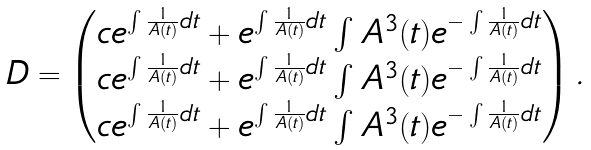Convert formula to latex. <formula><loc_0><loc_0><loc_500><loc_500>\begin{array} { l l } D = \begin{pmatrix} c e ^ { \int \frac { 1 } { A ( t ) } d t } + e ^ { \int \frac { 1 } { A ( t ) } d t } \int A ^ { 3 } ( t ) e ^ { - \int \frac { 1 } { A ( t ) } d t } \\ c e ^ { \int \frac { 1 } { A ( t ) } d t } + e ^ { \int \frac { 1 } { A ( t ) } d t } \int A ^ { 3 } ( t ) e ^ { - \int \frac { 1 } { A ( t ) } d t } \\ c e ^ { \int \frac { 1 } { A ( t ) } d t } + e ^ { \int \frac { 1 } { A ( t ) } d t } \int A ^ { 3 } ( t ) e ^ { - \int \frac { 1 } { A ( t ) } d t } \end{pmatrix} . \end{array}</formula> 